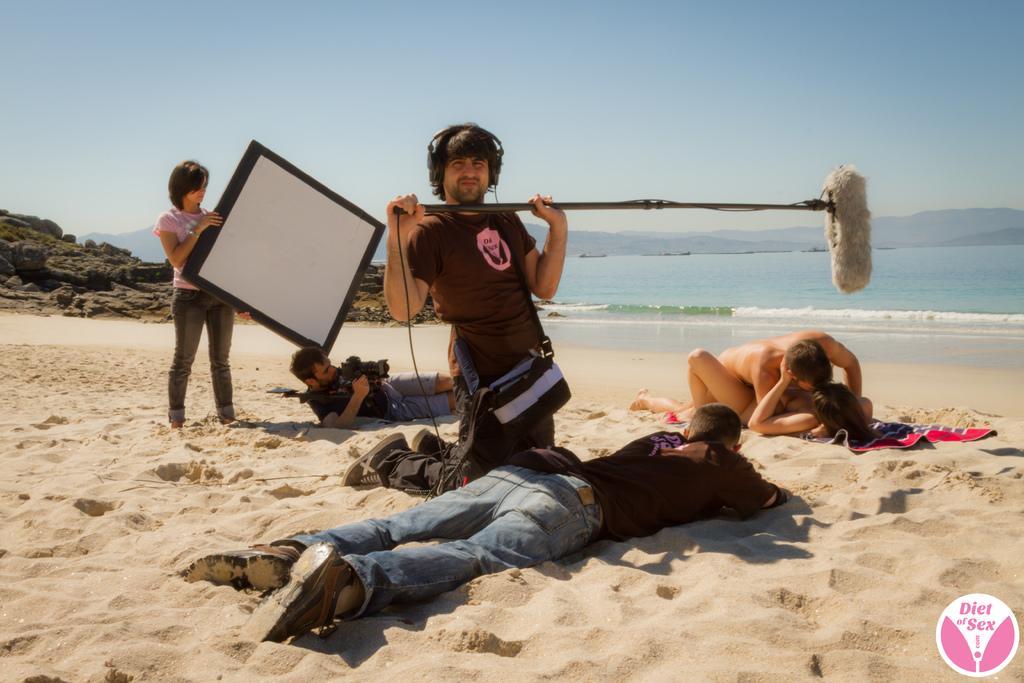Can you describe this image briefly? In this image, we can see people on the beach. There is a person in the middle of the image holding a stick with his hands. There is an another person holding a board with her hands. There is a rock hill on the left side of the image. At the top of the image, we can see the sky. 